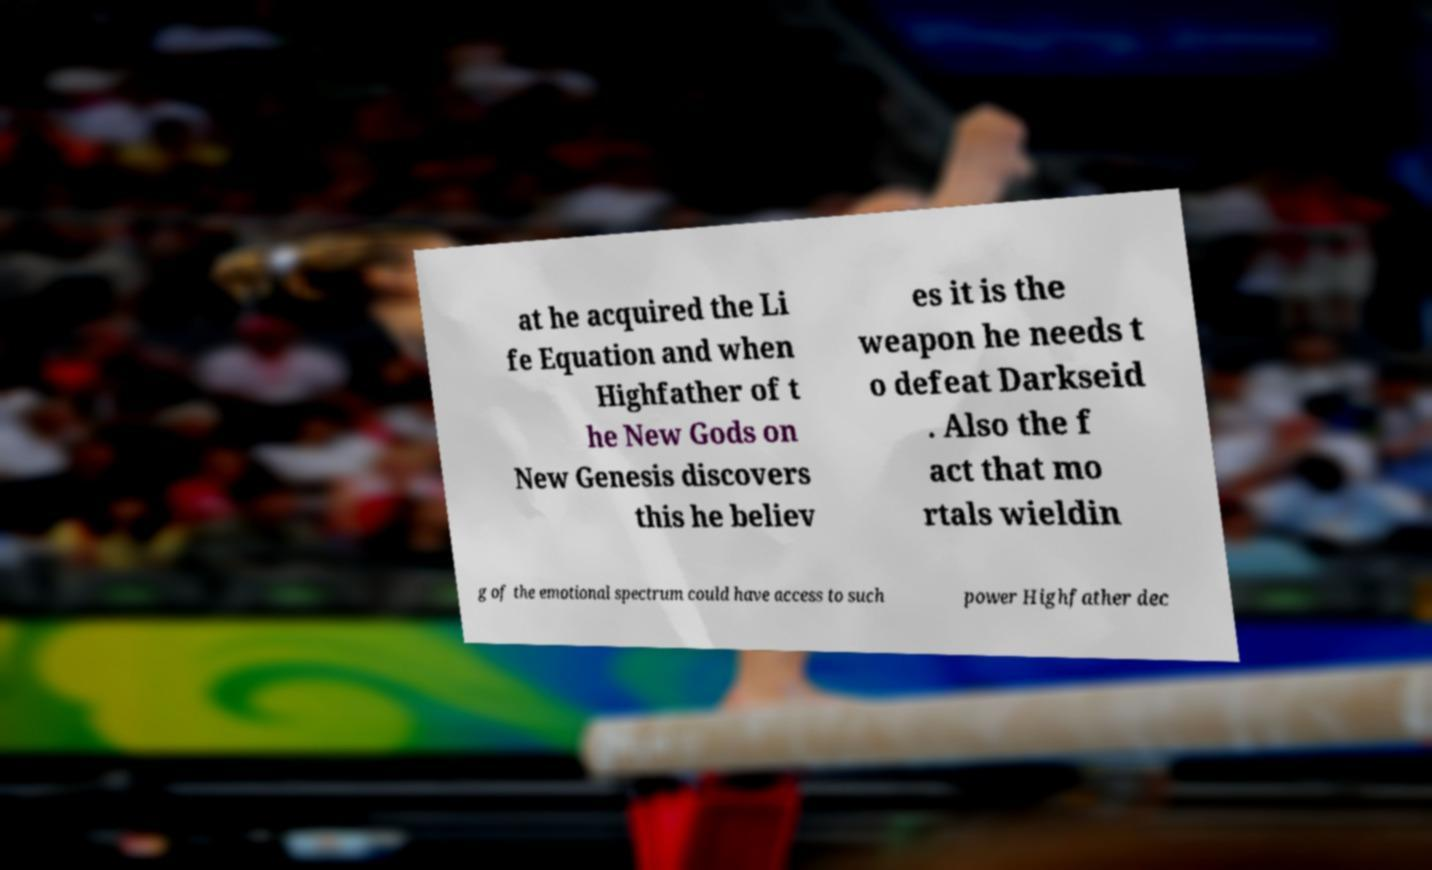What messages or text are displayed in this image? I need them in a readable, typed format. at he acquired the Li fe Equation and when Highfather of t he New Gods on New Genesis discovers this he believ es it is the weapon he needs t o defeat Darkseid . Also the f act that mo rtals wieldin g of the emotional spectrum could have access to such power Highfather dec 